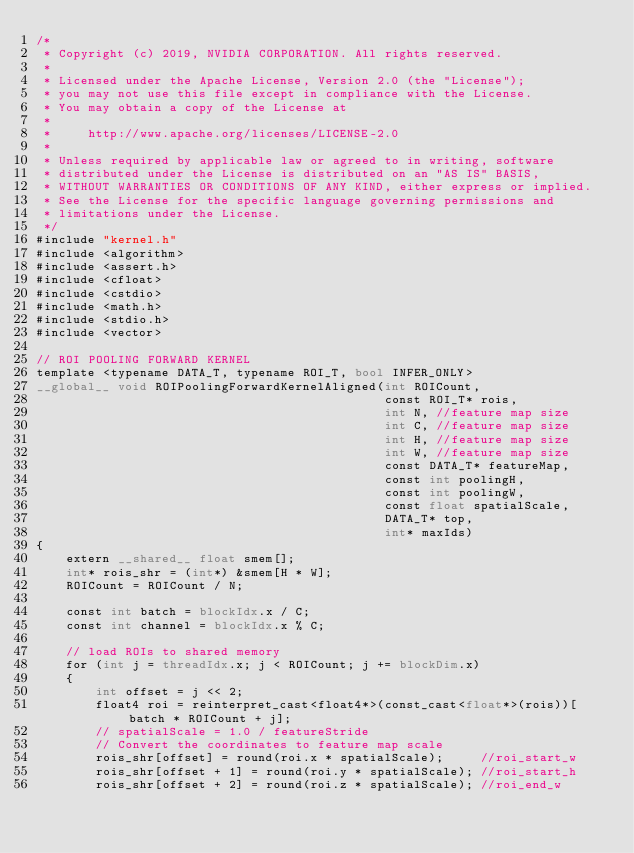Convert code to text. <code><loc_0><loc_0><loc_500><loc_500><_Cuda_>/*
 * Copyright (c) 2019, NVIDIA CORPORATION. All rights reserved.
 *
 * Licensed under the Apache License, Version 2.0 (the "License");
 * you may not use this file except in compliance with the License.
 * You may obtain a copy of the License at
 *
 *     http://www.apache.org/licenses/LICENSE-2.0
 *
 * Unless required by applicable law or agreed to in writing, software
 * distributed under the License is distributed on an "AS IS" BASIS,
 * WITHOUT WARRANTIES OR CONDITIONS OF ANY KIND, either express or implied.
 * See the License for the specific language governing permissions and
 * limitations under the License.
 */
#include "kernel.h"
#include <algorithm>
#include <assert.h>
#include <cfloat>
#include <cstdio>
#include <math.h>
#include <stdio.h>
#include <vector>

// ROI POOLING FORWARD KERNEL 
template <typename DATA_T, typename ROI_T, bool INFER_ONLY>
__global__ void ROIPoolingForwardKernelAligned(int ROICount,
                                               const ROI_T* rois,
                                               int N, //feature map size
                                               int C, //feature map size
                                               int H, //feature map size
                                               int W, //feature map size
                                               const DATA_T* featureMap,
                                               const int poolingH,
                                               const int poolingW,
                                               const float spatialScale,
                                               DATA_T* top,
                                               int* maxIds)
{
    extern __shared__ float smem[];
    int* rois_shr = (int*) &smem[H * W];
    ROICount = ROICount / N;

    const int batch = blockIdx.x / C;
    const int channel = blockIdx.x % C;

    // load ROIs to shared memory
    for (int j = threadIdx.x; j < ROICount; j += blockDim.x)
    {
        int offset = j << 2;
        float4 roi = reinterpret_cast<float4*>(const_cast<float*>(rois))[batch * ROICount + j];
        // spatialScale = 1.0 / featureStride
        // Convert the coordinates to feature map scale
        rois_shr[offset] = round(roi.x * spatialScale);     //roi_start_w
        rois_shr[offset + 1] = round(roi.y * spatialScale); //roi_start_h
        rois_shr[offset + 2] = round(roi.z * spatialScale); //roi_end_w</code> 